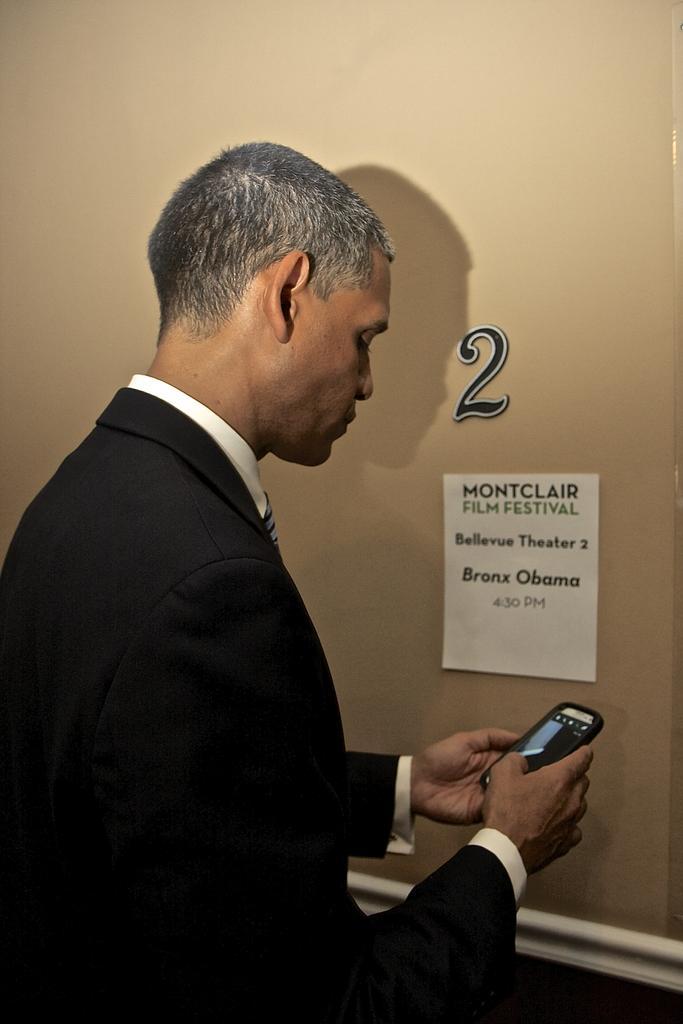In one or two sentences, can you explain what this image depicts? This is the image of a man who is standing and checking his mobile phone and at the background there is a paper and number 2 as stick to the wall. 